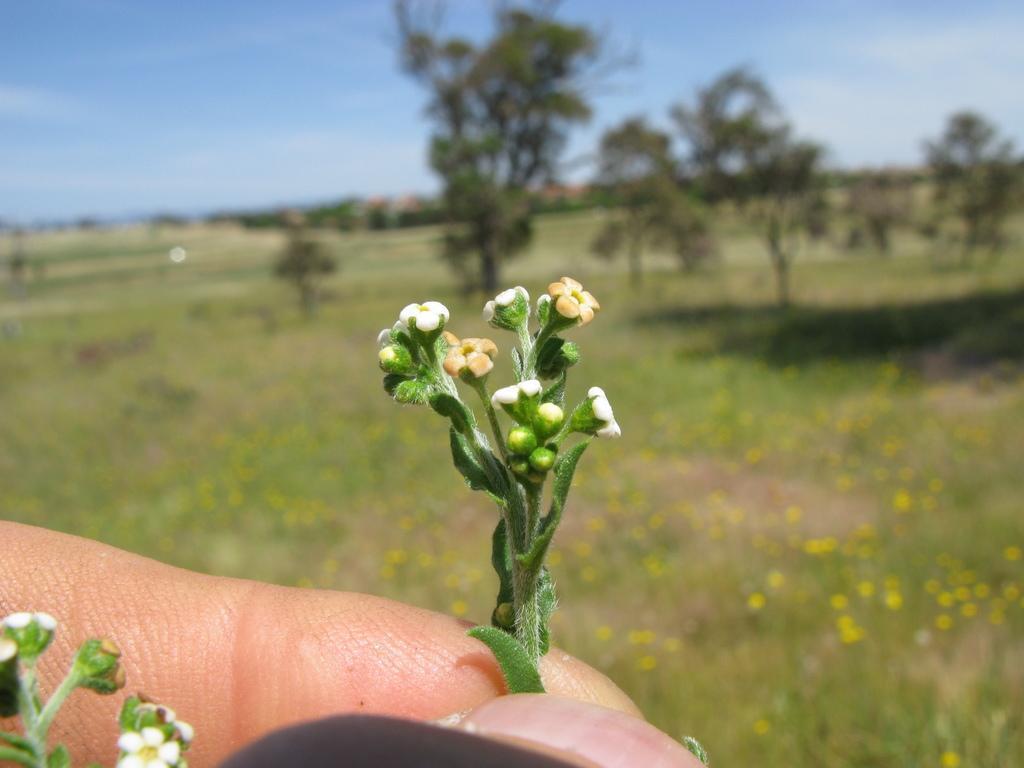Can you describe this image briefly? In this image we can see some person's fingers and we can also see that person is holding the plant. In the background, we can see the flower plants, trees and also the sky. 